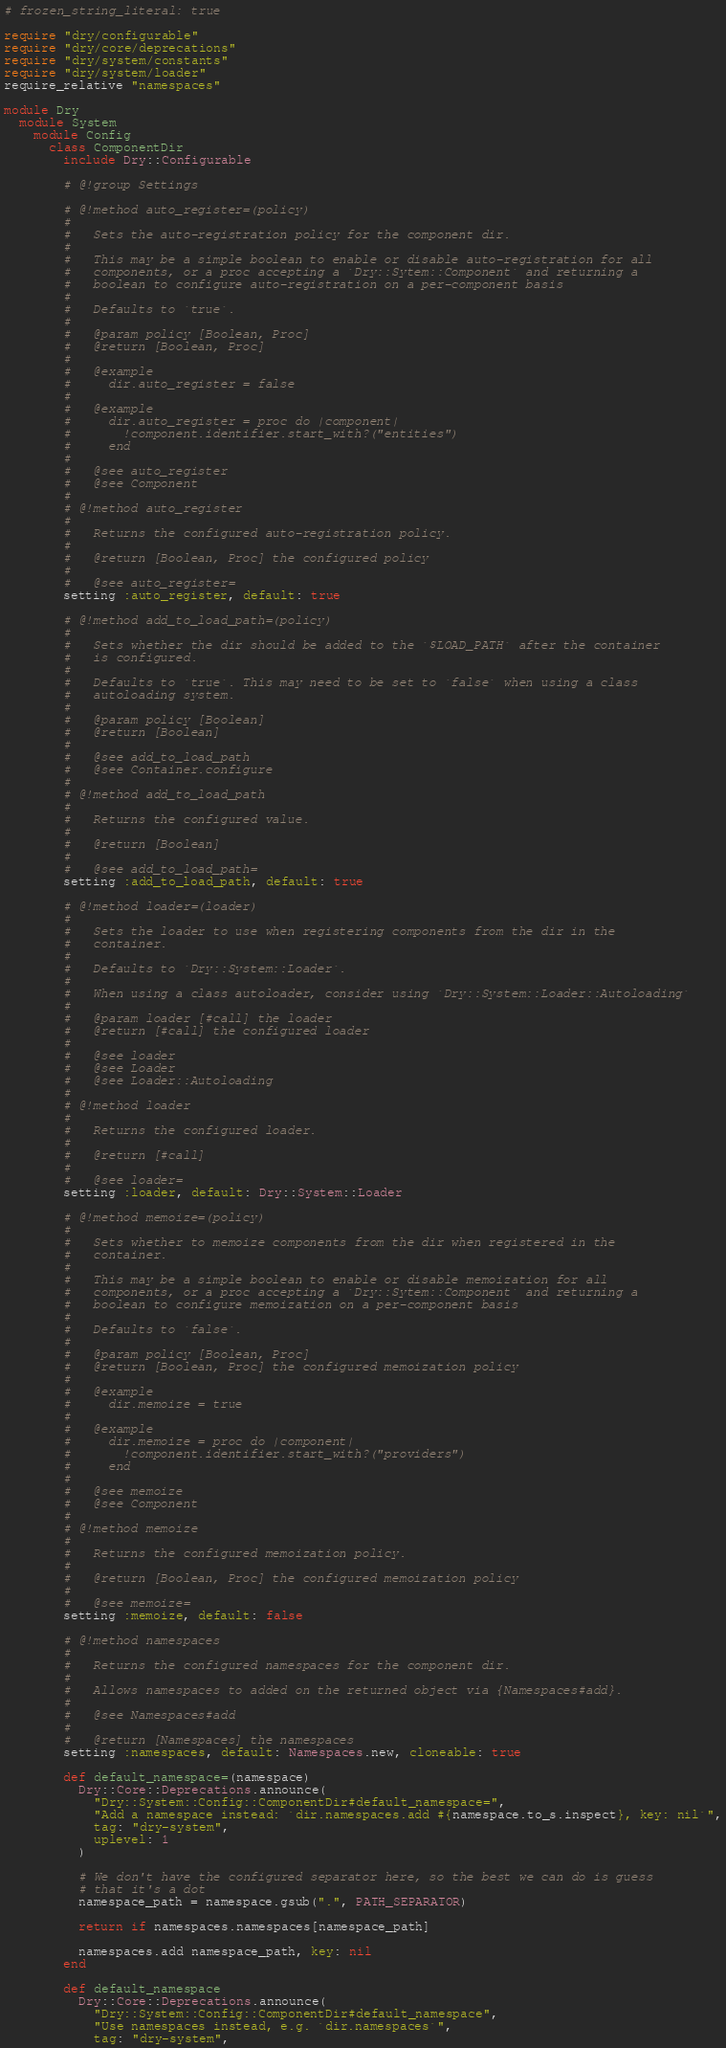Convert code to text. <code><loc_0><loc_0><loc_500><loc_500><_Ruby_># frozen_string_literal: true

require "dry/configurable"
require "dry/core/deprecations"
require "dry/system/constants"
require "dry/system/loader"
require_relative "namespaces"

module Dry
  module System
    module Config
      class ComponentDir
        include Dry::Configurable

        # @!group Settings

        # @!method auto_register=(policy)
        #
        #   Sets the auto-registration policy for the component dir.
        #
        #   This may be a simple boolean to enable or disable auto-registration for all
        #   components, or a proc accepting a `Dry::Sytem::Component` and returning a
        #   boolean to configure auto-registration on a per-component basis
        #
        #   Defaults to `true`.
        #
        #   @param policy [Boolean, Proc]
        #   @return [Boolean, Proc]
        #
        #   @example
        #     dir.auto_register = false
        #
        #   @example
        #     dir.auto_register = proc do |component|
        #       !component.identifier.start_with?("entities")
        #     end
        #
        #   @see auto_register
        #   @see Component
        #
        # @!method auto_register
        #
        #   Returns the configured auto-registration policy.
        #
        #   @return [Boolean, Proc] the configured policy
        #
        #   @see auto_register=
        setting :auto_register, default: true

        # @!method add_to_load_path=(policy)
        #
        #   Sets whether the dir should be added to the `$LOAD_PATH` after the container
        #   is configured.
        #
        #   Defaults to `true`. This may need to be set to `false` when using a class
        #   autoloading system.
        #
        #   @param policy [Boolean]
        #   @return [Boolean]
        #
        #   @see add_to_load_path
        #   @see Container.configure
        #
        # @!method add_to_load_path
        #
        #   Returns the configured value.
        #
        #   @return [Boolean]
        #
        #   @see add_to_load_path=
        setting :add_to_load_path, default: true

        # @!method loader=(loader)
        #
        #   Sets the loader to use when registering components from the dir in the
        #   container.
        #
        #   Defaults to `Dry::System::Loader`.
        #
        #   When using a class autoloader, consider using `Dry::System::Loader::Autoloading`
        #
        #   @param loader [#call] the loader
        #   @return [#call] the configured loader
        #
        #   @see loader
        #   @see Loader
        #   @see Loader::Autoloading
        #
        # @!method loader
        #
        #   Returns the configured loader.
        #
        #   @return [#call]
        #
        #   @see loader=
        setting :loader, default: Dry::System::Loader

        # @!method memoize=(policy)
        #
        #   Sets whether to memoize components from the dir when registered in the
        #   container.
        #
        #   This may be a simple boolean to enable or disable memoization for all
        #   components, or a proc accepting a `Dry::Sytem::Component` and returning a
        #   boolean to configure memoization on a per-component basis
        #
        #   Defaults to `false`.
        #
        #   @param policy [Boolean, Proc]
        #   @return [Boolean, Proc] the configured memoization policy
        #
        #   @example
        #     dir.memoize = true
        #
        #   @example
        #     dir.memoize = proc do |component|
        #       !component.identifier.start_with?("providers")
        #     end
        #
        #   @see memoize
        #   @see Component
        #
        # @!method memoize
        #
        #   Returns the configured memoization policy.
        #
        #   @return [Boolean, Proc] the configured memoization policy
        #
        #   @see memoize=
        setting :memoize, default: false

        # @!method namespaces
        #
        #   Returns the configured namespaces for the component dir.
        #
        #   Allows namespaces to added on the returned object via {Namespaces#add}.
        #
        #   @see Namespaces#add
        #
        #   @return [Namespaces] the namespaces
        setting :namespaces, default: Namespaces.new, cloneable: true

        def default_namespace=(namespace)
          Dry::Core::Deprecations.announce(
            "Dry::System::Config::ComponentDir#default_namespace=",
            "Add a namespace instead: `dir.namespaces.add #{namespace.to_s.inspect}, key: nil`",
            tag: "dry-system",
            uplevel: 1
          )

          # We don't have the configured separator here, so the best we can do is guess
          # that it's a dot
          namespace_path = namespace.gsub(".", PATH_SEPARATOR)

          return if namespaces.namespaces[namespace_path]

          namespaces.add namespace_path, key: nil
        end

        def default_namespace
          Dry::Core::Deprecations.announce(
            "Dry::System::Config::ComponentDir#default_namespace",
            "Use namespaces instead, e.g. `dir.namespaces`",
            tag: "dry-system",</code> 